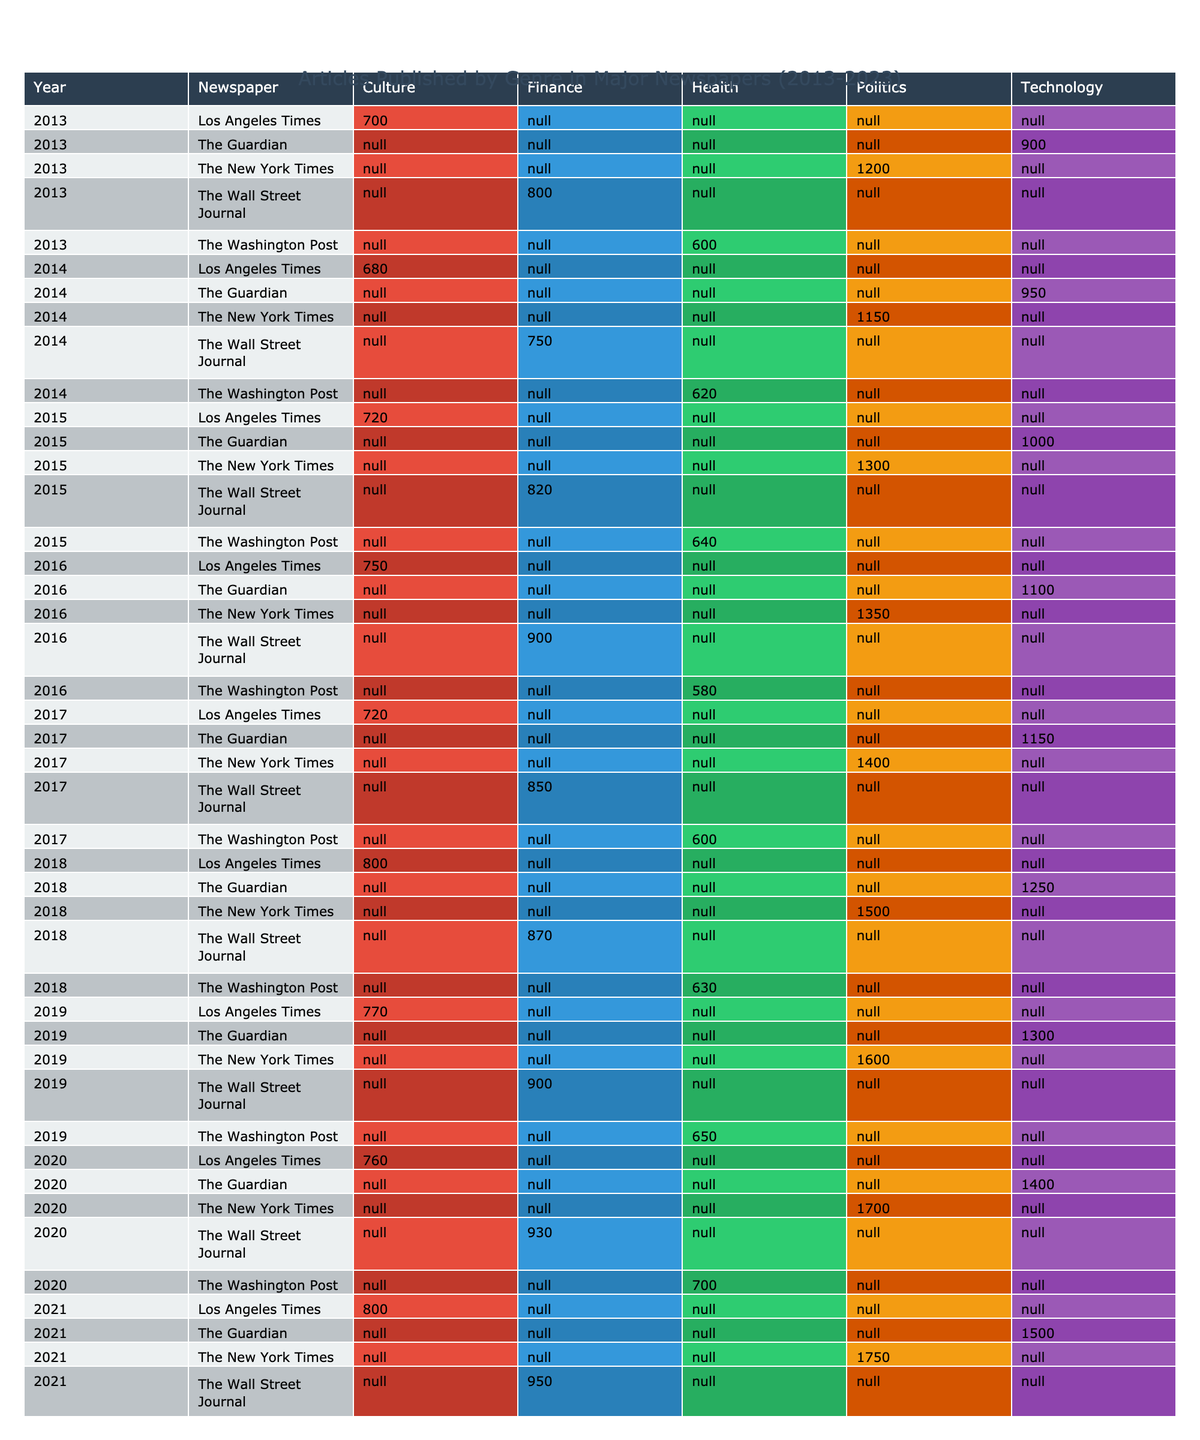What's the total number of articles published in 2023 across all genres? To find the total number of articles published in 2023, I will add the number of articles from each genre for that year: Politics (1850) + Technology (1600) + Health (780) + Finance (1000) + Culture (840) = 5270.
Answer: 5270 Which newspaper published the highest number of political articles in 2019? Looking at the table for 2019, I see that The New York Times published 1600 articles in the Politics genre, which is higher than any other newspaper for that year.
Answer: The New York Times What genre had the lowest number of published articles in 2016? In 2016, the number of articles published by genre is as follows: Politics (1350), Technology (1100), Health (580), Finance (900), Culture (750). The genre with the lowest articles is Health with 580 articles.
Answer: Health Did The Guardian publish more technology articles in 2022 compared to 2021? Comparing the numbers, The Guardian published 1550 technology articles in 2022 and 1500 in 2021. Since 1550 is greater than 1500, the answer is yes.
Answer: Yes What was the average number of health articles published by The Washington Post from 2013 to 2023? The Washington Post published the following number of health articles: 600 (2013), 620 (2014), 640 (2015), 580 (2016), 600 (2017), 630 (2018), 650 (2019), 700 (2020), 730 (2021), 740 (2022), and 780 (2023). The total is 6300. There are 11 years, so the average is 6300 / 11 = 572.73.
Answer: 572.73 Which genre trend shows the largest increase in articles published from 2013 to 2023? From 2013 to 2023, the article counts for Politics are 1200 to 1850 (increase of 650), for Technology are 900 to 1600 (increase of 700), for Health are 600 to 780 (increase of 180), for Finance are 800 to 1000 (increase of 200), and for Culture are 700 to 840 (increase of 140). The largest increase is in Technology with an increase of 700 articles.
Answer: Technology 